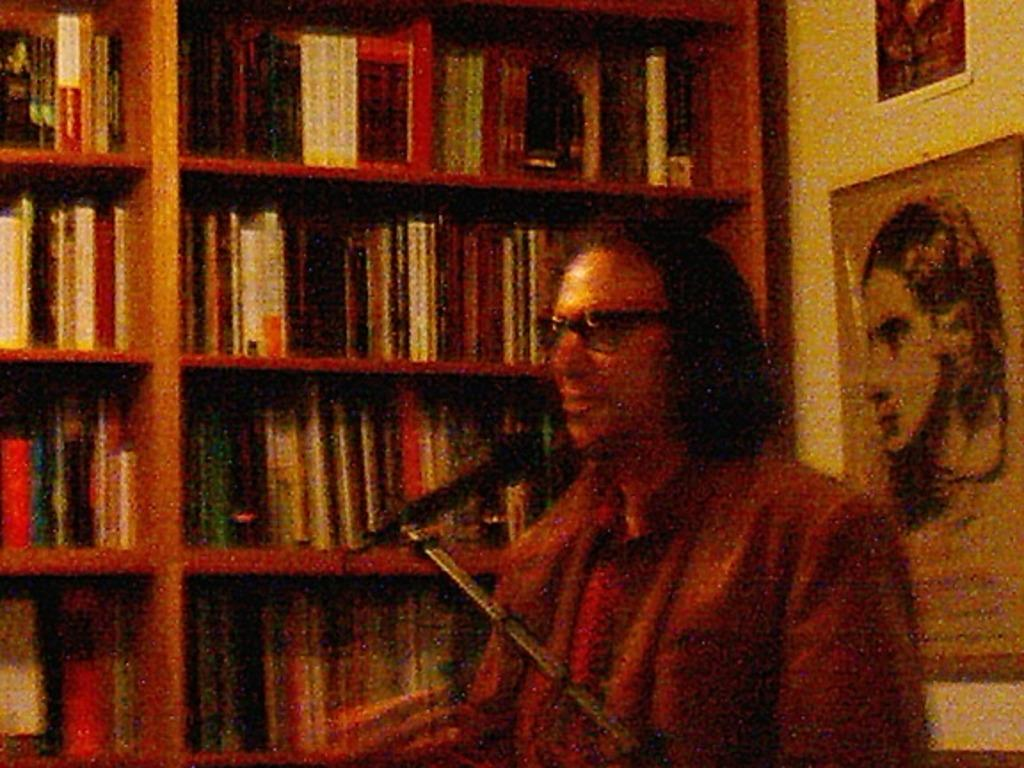<image>
Provide a brief description of the given image. A man in a red shirt with microphone and a book shelf full of books behind him 